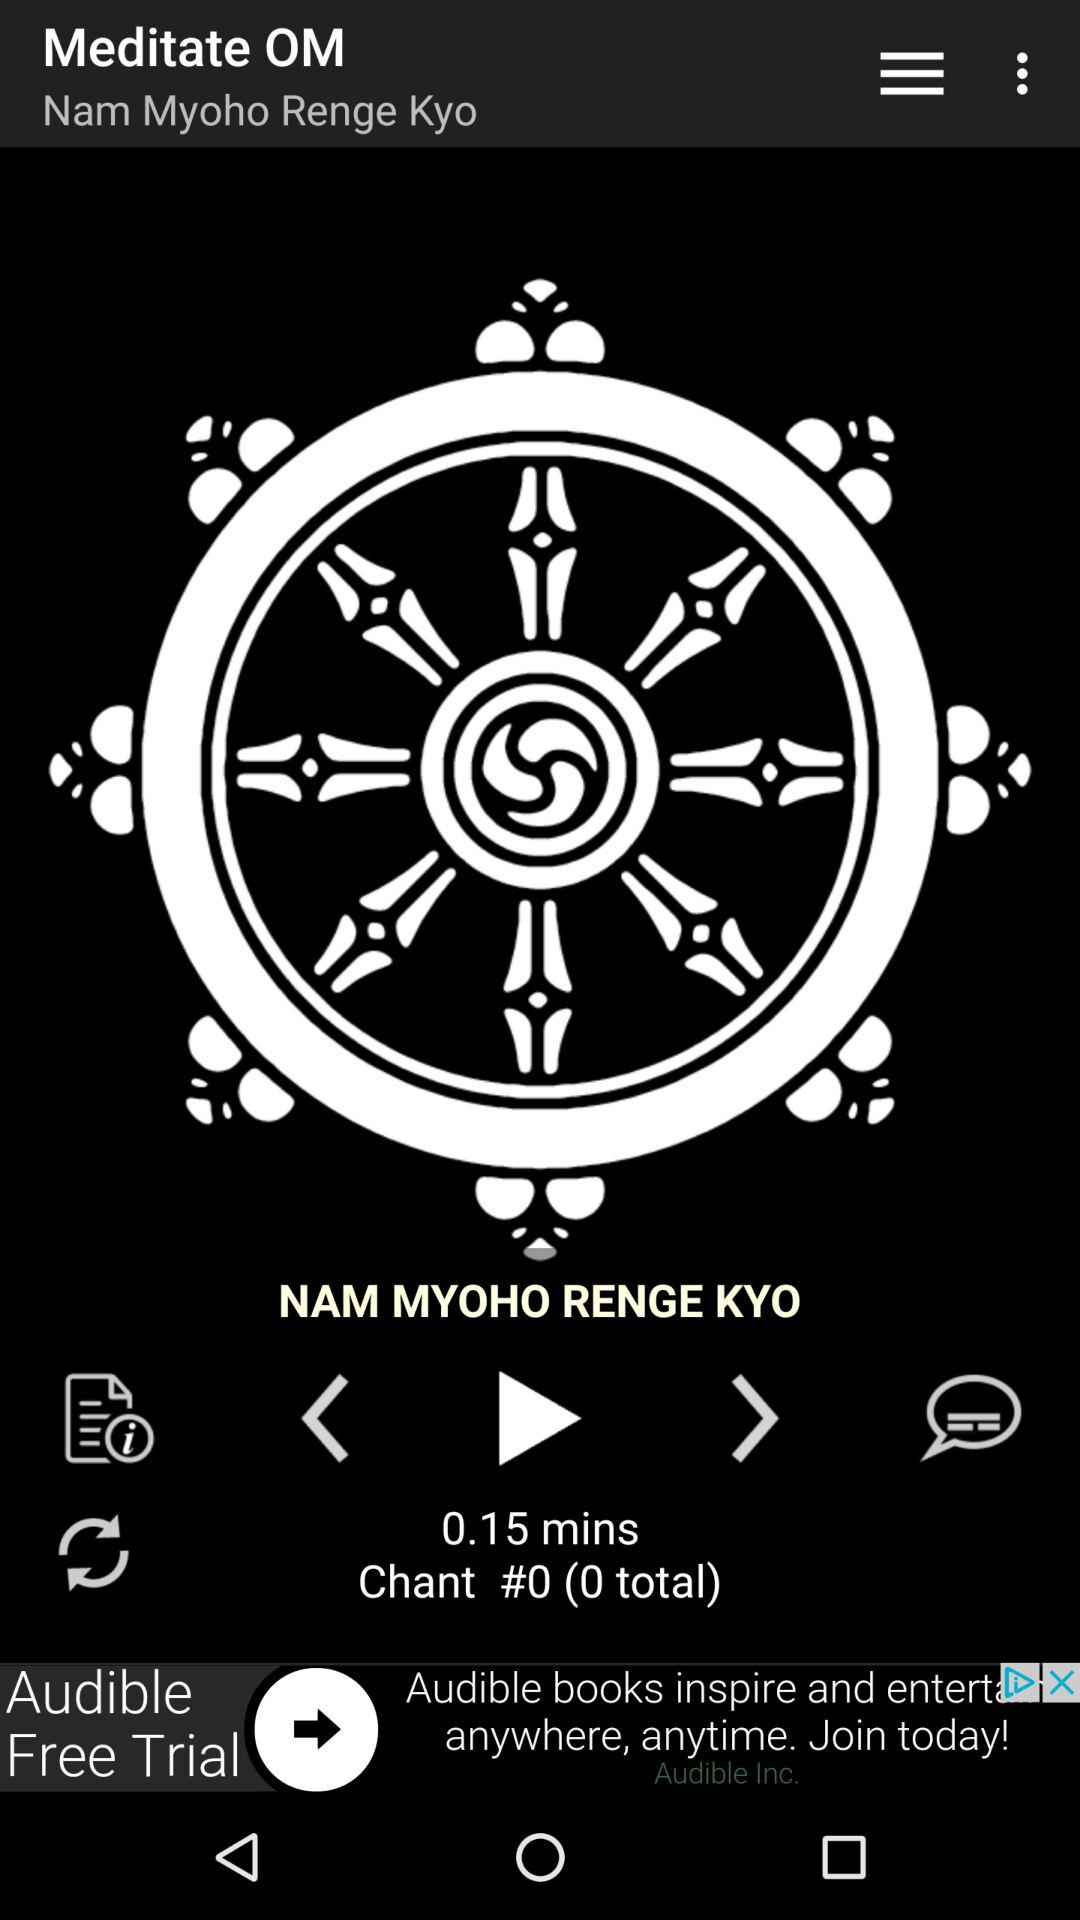How long is the chant?
Answer the question using a single word or phrase. 0.15 mins 